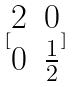<formula> <loc_0><loc_0><loc_500><loc_500>[ \begin{matrix} 2 & 0 \\ 0 & \frac { 1 } { 2 } \end{matrix} ]</formula> 